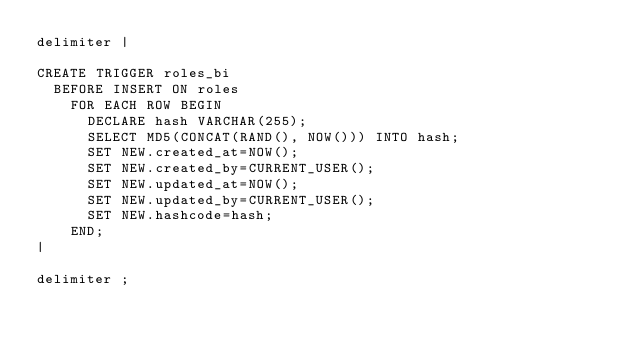Convert code to text. <code><loc_0><loc_0><loc_500><loc_500><_SQL_>delimiter |

CREATE TRIGGER roles_bi
  BEFORE INSERT ON roles
    FOR EACH ROW BEGIN
      DECLARE hash VARCHAR(255);
      SELECT MD5(CONCAT(RAND(), NOW())) INTO hash;
	  SET NEW.created_at=NOW();
      SET NEW.created_by=CURRENT_USER();
      SET NEW.updated_at=NOW();
      SET NEW.updated_by=CURRENT_USER();
      SET NEW.hashcode=hash;
    END;
|

delimiter ;

</code> 